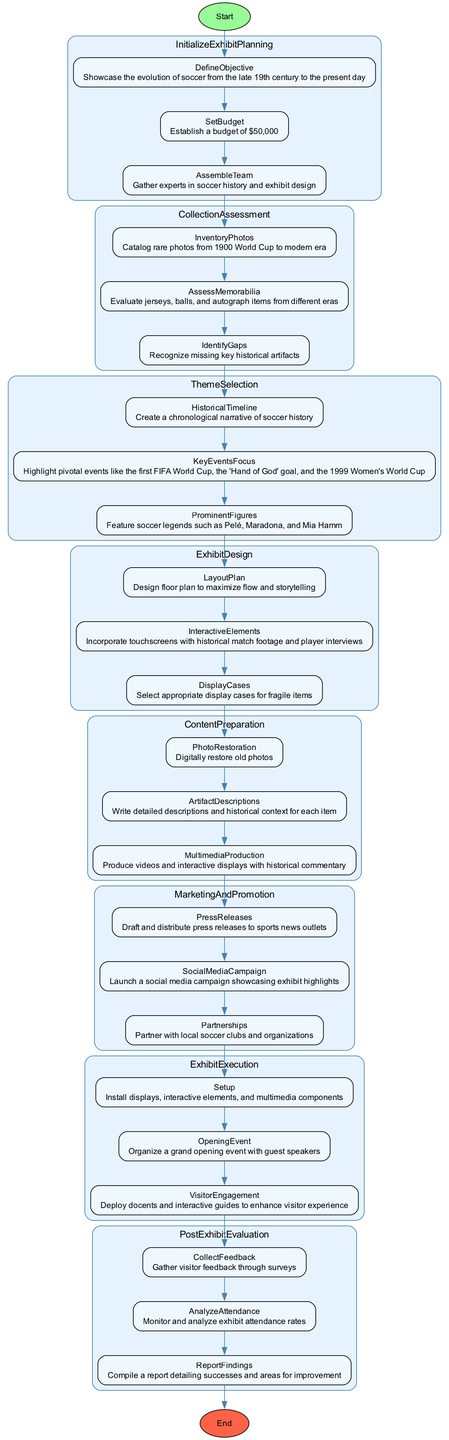What is the objective defined in the exhibit planning? The objective defined is to showcase the evolution of soccer from the late 19th century to the present day, which is explicitly mentioned in the "DefineObjective" node.
Answer: Showcase the evolution of soccer from the late 19th century to the present day How many steps are there in the Collection Assessment phase? The Collection Assessment phase consists of three steps: Inventory Photos, Assess Memorabilia, and Identify Gaps, as detailed within that section of the diagram.
Answer: 3 What is the budget set for the exhibit? The budget set is explicitly stated in the "SetBudget" node as $50,000.
Answer: $50,000 Which phase includes the implementation of interactive elements? The implementation of interactive elements is part of the Exhibit Design phase, where "InteractiveElements" specifically mentions incorporating touchscreens and multimedia.
Answer: Exhibit Design How does the Exhibit Execution phase connect to the Post Exhibit Evaluation phase? The Exhibit Execution phase ends with the visitor engagement step, which is followed by the Post Exhibit Evaluation phase that starts with the Collect Feedback step, establishing a direct flow from exhibit execution to evaluation.
Answer: Direct flow from Exhibit Execution to Post Exhibit Evaluation Which historical event is highlighted in the Theme Selection phase? The highlighted historical event in the Theme Selection phase includes several pivotal moments, specifically the first FIFA World Cup, which serves as a key focus.
Answer: First FIFA World Cup What is one key component of the Marketing and Promotion phase? A key component in the Marketing and Promotion phase is launching a social media campaign, as noted in the "SocialMediaCampaign" node.
Answer: Social media campaign What is one action taken in the Content Preparation phase? One action in the Content Preparation phase is digitally restoring old photos, which is specified in the "PhotoRestoration" step of that phase.
Answer: Digitally restore old photos 